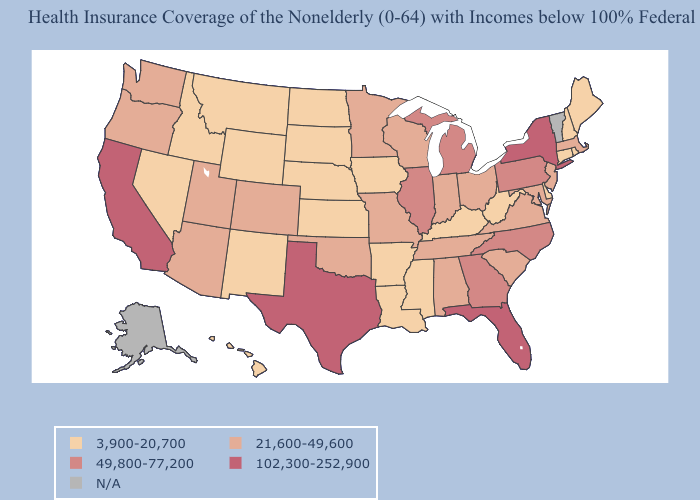Is the legend a continuous bar?
Short answer required. No. Among the states that border Arizona , does Colorado have the lowest value?
Short answer required. No. What is the value of Minnesota?
Be succinct. 21,600-49,600. Name the states that have a value in the range 21,600-49,600?
Write a very short answer. Alabama, Arizona, Colorado, Indiana, Maryland, Massachusetts, Minnesota, Missouri, New Jersey, Ohio, Oklahoma, Oregon, South Carolina, Tennessee, Utah, Virginia, Washington, Wisconsin. Which states have the lowest value in the Northeast?
Be succinct. Connecticut, Maine, New Hampshire, Rhode Island. Name the states that have a value in the range N/A?
Be succinct. Alaska, Vermont. What is the value of Arizona?
Concise answer only. 21,600-49,600. Does Kentucky have the lowest value in the South?
Be succinct. Yes. What is the value of Maryland?
Concise answer only. 21,600-49,600. What is the highest value in the Northeast ?
Be succinct. 102,300-252,900. What is the lowest value in the USA?
Keep it brief. 3,900-20,700. Does Alabama have the lowest value in the USA?
Answer briefly. No. What is the value of Iowa?
Write a very short answer. 3,900-20,700. 